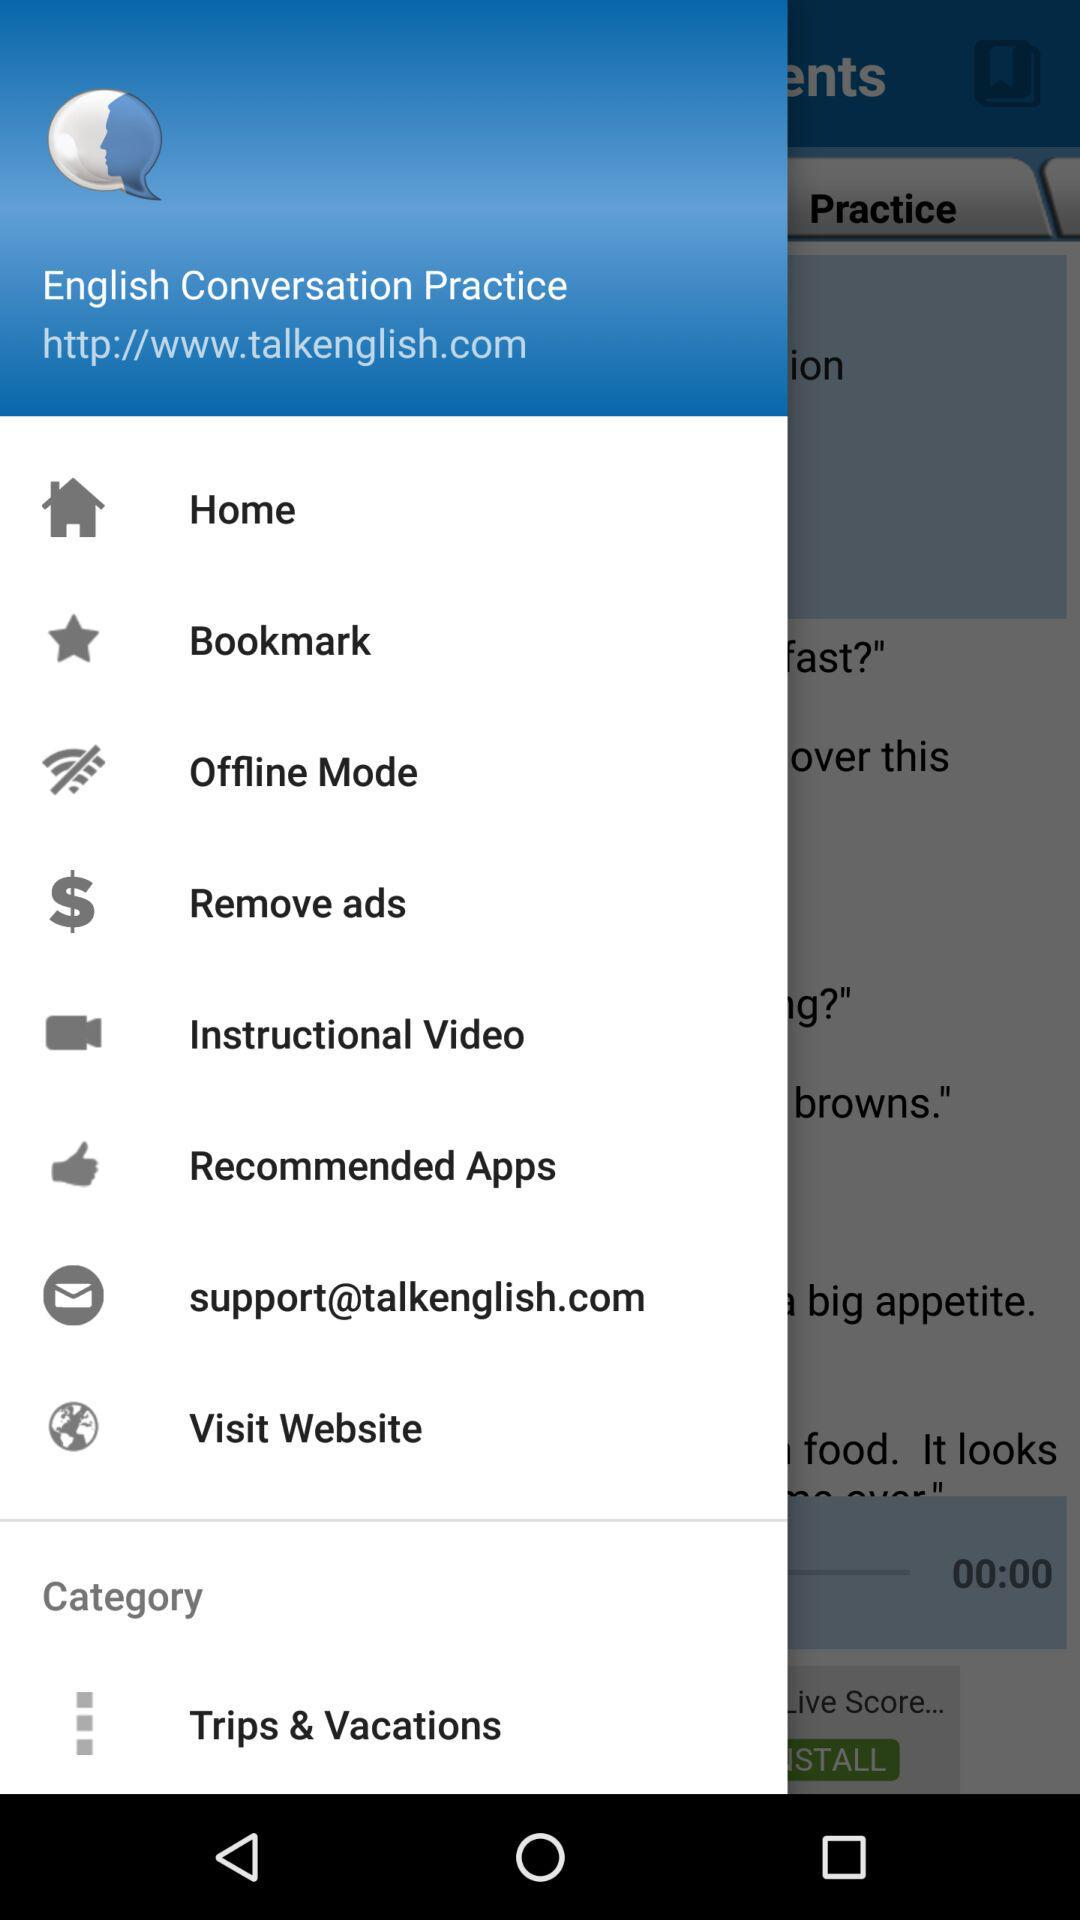What is the support website of this application?
When the provided information is insufficient, respond with <no answer>. <no answer> 